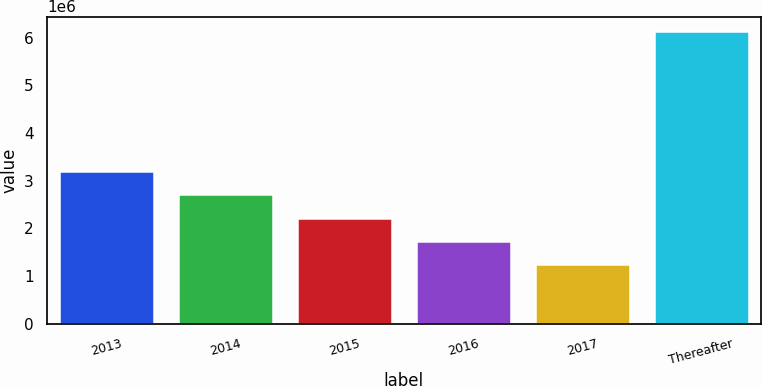<chart> <loc_0><loc_0><loc_500><loc_500><bar_chart><fcel>2013<fcel>2014<fcel>2015<fcel>2016<fcel>2017<fcel>Thereafter<nl><fcel>3.2039e+06<fcel>2.7154e+06<fcel>2.2269e+06<fcel>1.7384e+06<fcel>1.2499e+06<fcel>6.1349e+06<nl></chart> 